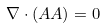Convert formula to latex. <formula><loc_0><loc_0><loc_500><loc_500>\nabla \cdot ( A A ) = 0</formula> 